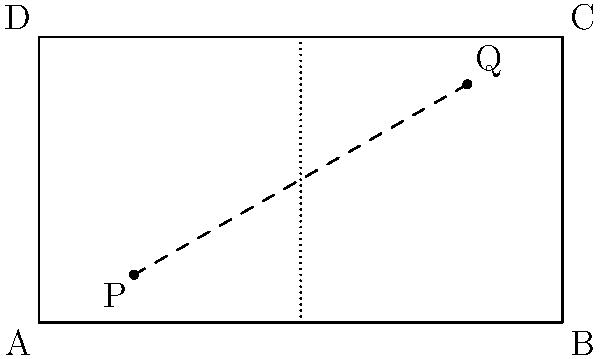In a lacrosse field represented by the rectangle ABCD, where AB = 110 yards and BC = 60 yards, a Calgary Roughnecks player starts at point P(20,10) and needs to reach point Q(90,50). What is the shortest distance the player needs to run to get from P to Q? To find the shortest distance between two points on a plane, we can use the distance formula derived from the Pythagorean theorem:

1) The distance formula is: $$d = \sqrt{(x_2 - x_1)^2 + (y_2 - y_1)^2}$$

2) We have the coordinates:
   P(x₁, y₁) = (20, 10)
   Q(x₂, y₂) = (90, 50)

3) Let's substitute these into the formula:
   $$d = \sqrt{(90 - 20)^2 + (50 - 10)^2}$$

4) Simplify inside the parentheses:
   $$d = \sqrt{70^2 + 40^2}$$

5) Calculate the squares:
   $$d = \sqrt{4900 + 1600}$$

6) Add under the square root:
   $$d = \sqrt{6500}$$

7) Simplify the square root:
   $$d = 10\sqrt{65} \approx 80.62$$

Therefore, the shortest distance the player needs to run is $10\sqrt{65}$ yards, which is approximately 80.62 yards.
Answer: $10\sqrt{65}$ yards 